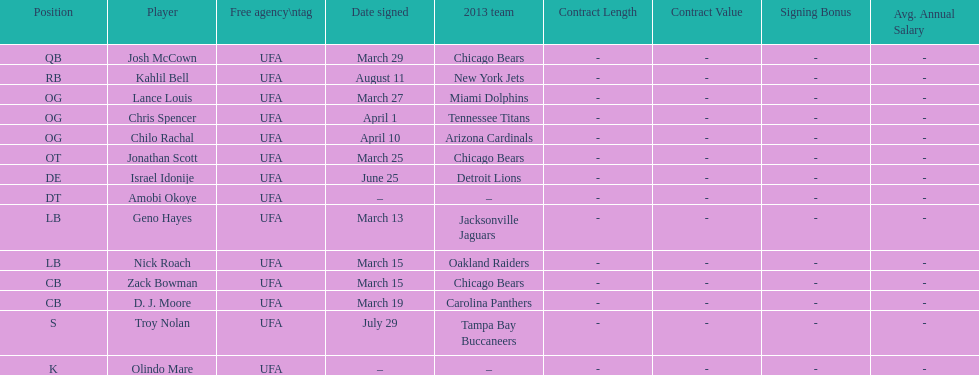How many players play cb or og? 5. 